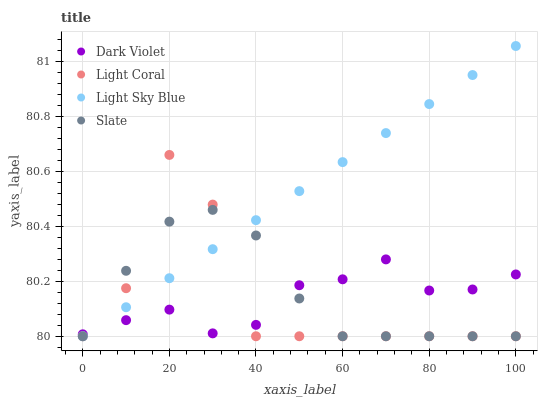Does Light Coral have the minimum area under the curve?
Answer yes or no. Yes. Does Light Sky Blue have the maximum area under the curve?
Answer yes or no. Yes. Does Slate have the minimum area under the curve?
Answer yes or no. No. Does Slate have the maximum area under the curve?
Answer yes or no. No. Is Light Sky Blue the smoothest?
Answer yes or no. Yes. Is Light Coral the roughest?
Answer yes or no. Yes. Is Slate the smoothest?
Answer yes or no. No. Is Slate the roughest?
Answer yes or no. No. Does Light Coral have the lowest value?
Answer yes or no. Yes. Does Dark Violet have the lowest value?
Answer yes or no. No. Does Light Sky Blue have the highest value?
Answer yes or no. Yes. Does Slate have the highest value?
Answer yes or no. No. Does Slate intersect Light Coral?
Answer yes or no. Yes. Is Slate less than Light Coral?
Answer yes or no. No. Is Slate greater than Light Coral?
Answer yes or no. No. 